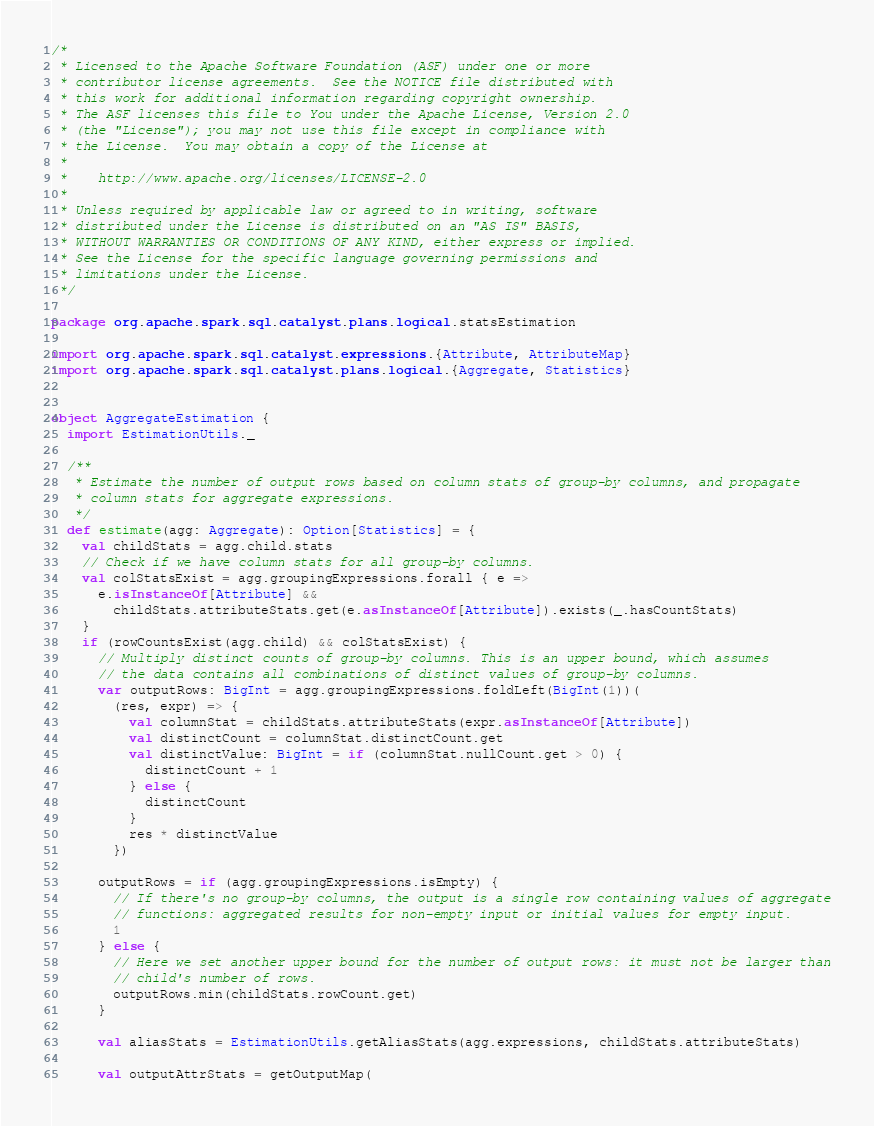<code> <loc_0><loc_0><loc_500><loc_500><_Scala_>/*
 * Licensed to the Apache Software Foundation (ASF) under one or more
 * contributor license agreements.  See the NOTICE file distributed with
 * this work for additional information regarding copyright ownership.
 * The ASF licenses this file to You under the Apache License, Version 2.0
 * (the "License"); you may not use this file except in compliance with
 * the License.  You may obtain a copy of the License at
 *
 *    http://www.apache.org/licenses/LICENSE-2.0
 *
 * Unless required by applicable law or agreed to in writing, software
 * distributed under the License is distributed on an "AS IS" BASIS,
 * WITHOUT WARRANTIES OR CONDITIONS OF ANY KIND, either express or implied.
 * See the License for the specific language governing permissions and
 * limitations under the License.
 */

package org.apache.spark.sql.catalyst.plans.logical.statsEstimation

import org.apache.spark.sql.catalyst.expressions.{Attribute, AttributeMap}
import org.apache.spark.sql.catalyst.plans.logical.{Aggregate, Statistics}


object AggregateEstimation {
  import EstimationUtils._

  /**
   * Estimate the number of output rows based on column stats of group-by columns, and propagate
   * column stats for aggregate expressions.
   */
  def estimate(agg: Aggregate): Option[Statistics] = {
    val childStats = agg.child.stats
    // Check if we have column stats for all group-by columns.
    val colStatsExist = agg.groupingExpressions.forall { e =>
      e.isInstanceOf[Attribute] &&
        childStats.attributeStats.get(e.asInstanceOf[Attribute]).exists(_.hasCountStats)
    }
    if (rowCountsExist(agg.child) && colStatsExist) {
      // Multiply distinct counts of group-by columns. This is an upper bound, which assumes
      // the data contains all combinations of distinct values of group-by columns.
      var outputRows: BigInt = agg.groupingExpressions.foldLeft(BigInt(1))(
        (res, expr) => {
          val columnStat = childStats.attributeStats(expr.asInstanceOf[Attribute])
          val distinctCount = columnStat.distinctCount.get
          val distinctValue: BigInt = if (columnStat.nullCount.get > 0) {
            distinctCount + 1
          } else {
            distinctCount
          }
          res * distinctValue
        })

      outputRows = if (agg.groupingExpressions.isEmpty) {
        // If there's no group-by columns, the output is a single row containing values of aggregate
        // functions: aggregated results for non-empty input or initial values for empty input.
        1
      } else {
        // Here we set another upper bound for the number of output rows: it must not be larger than
        // child's number of rows.
        outputRows.min(childStats.rowCount.get)
      }

      val aliasStats = EstimationUtils.getAliasStats(agg.expressions, childStats.attributeStats)

      val outputAttrStats = getOutputMap(</code> 